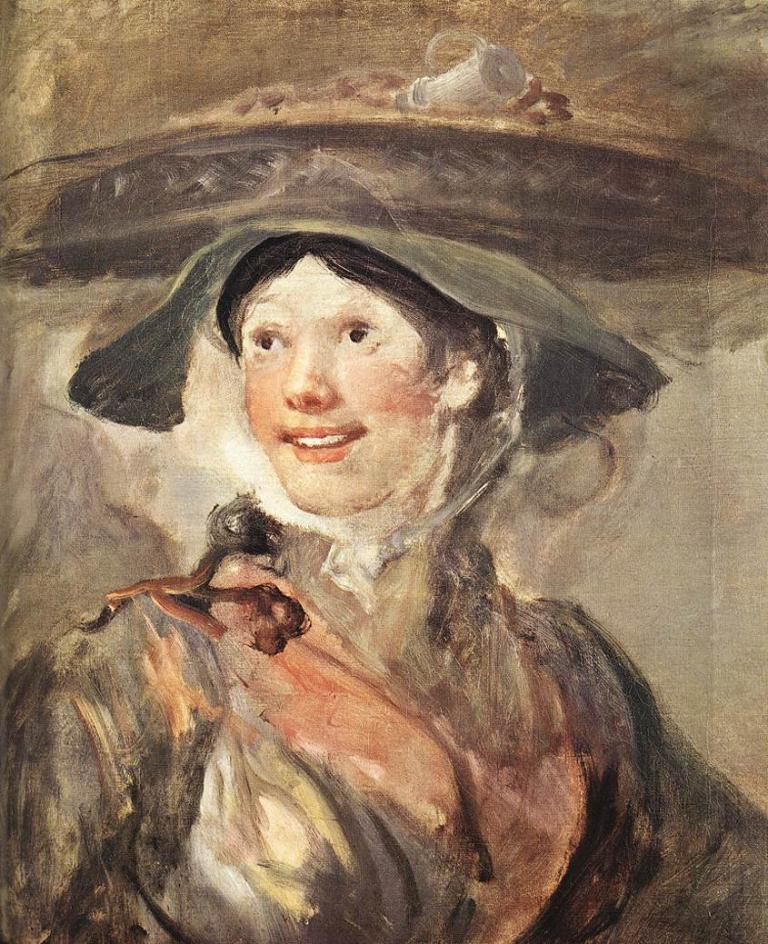What is the main subject of the image? The main subject of the image is a painting. What does the painting depict? The painting depicts a woman. What type of summer clothing is the woman wearing in the painting? The image does not provide information about the woman's clothing or the season, so it cannot be determined from the image. What type of power does the woman in the painting possess? The image does not provide information about the woman's abilities or powers, so it cannot be determined from the image. Is there a band performing in the painting? The image does not depict a band or any musical performance, so it cannot be determined from the image. 